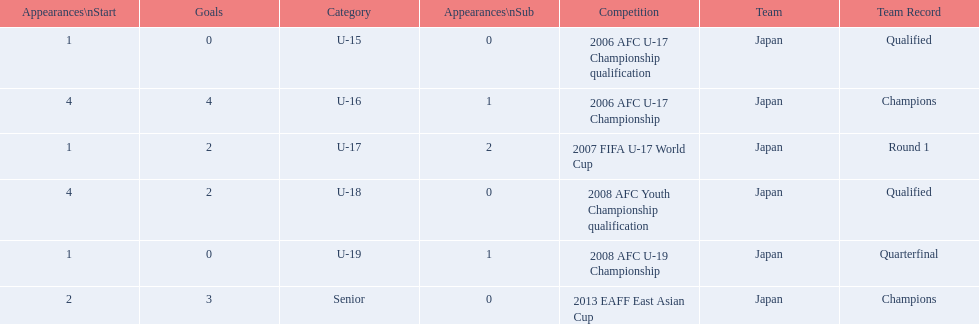Which competitions has yoichiro kakitani participated in? 2006 AFC U-17 Championship qualification, 2006 AFC U-17 Championship, 2007 FIFA U-17 World Cup, 2008 AFC Youth Championship qualification, 2008 AFC U-19 Championship, 2013 EAFF East Asian Cup. How many times did he start during each competition? 1, 4, 1, 4, 1, 2. How many goals did he score during those? 0, 4, 2, 2, 0, 3. And during which competition did yoichiro achieve the most starts and goals? 2006 AFC U-17 Championship. 